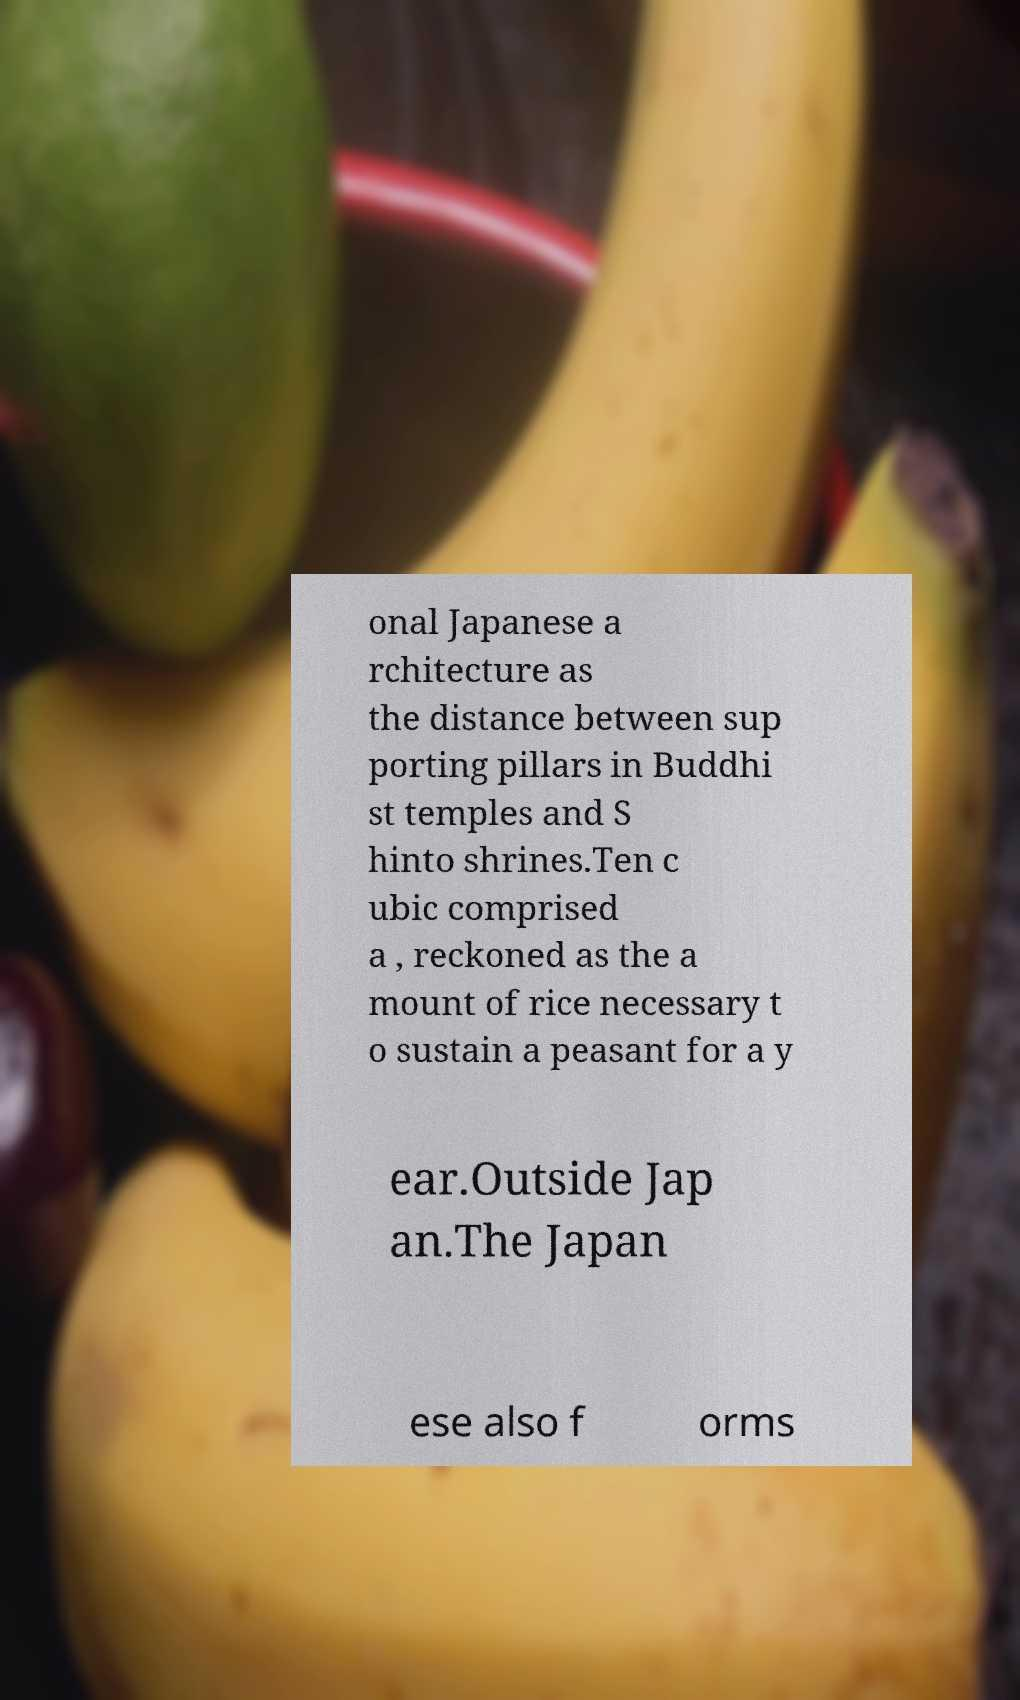For documentation purposes, I need the text within this image transcribed. Could you provide that? onal Japanese a rchitecture as the distance between sup porting pillars in Buddhi st temples and S hinto shrines.Ten c ubic comprised a , reckoned as the a mount of rice necessary t o sustain a peasant for a y ear.Outside Jap an.The Japan ese also f orms 